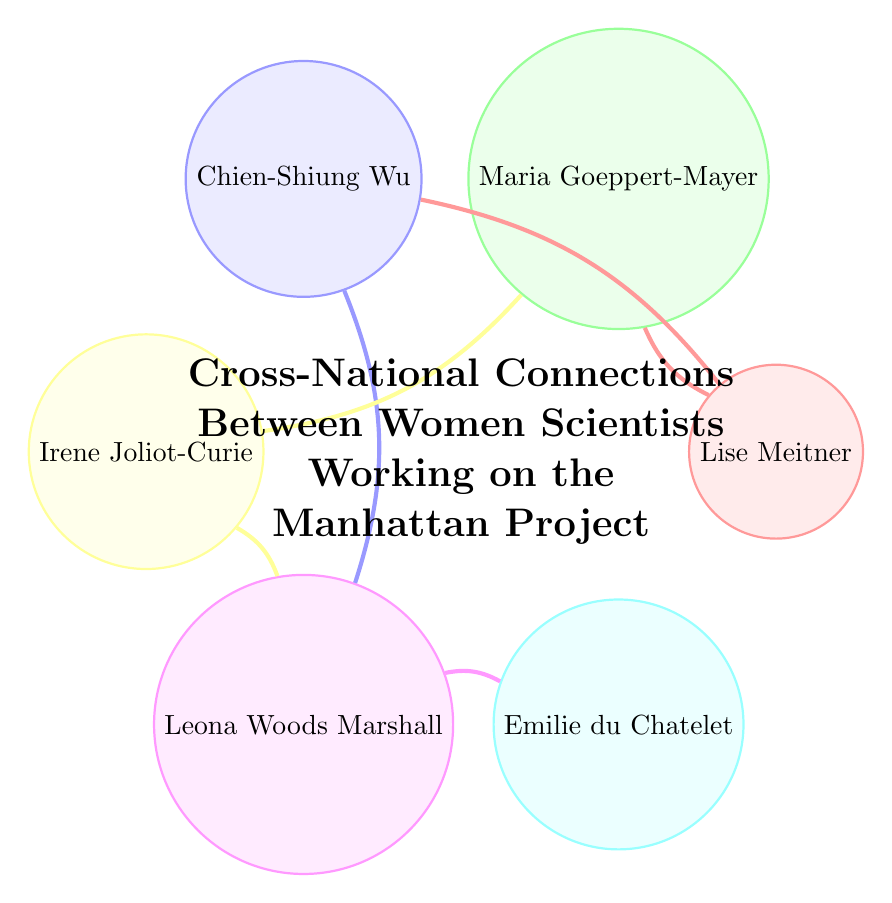How many nodes are in the diagram? The diagram shows six distinct names represented as nodes: Lise Meitner, Maria Goeppert-Mayer, Chien-Shiung Wu, Irene Joliot-Curie, Leona Woods Marshall, and Emilie du Chatelet.
Answer: 6 What is the connection between Lise Meitner and Chien-Shiung Wu? In the diagram, there is a direct link represented between Lise Meitner and Chien-Shiung Wu, indicating they are connected.
Answer: Connected How many total connections (links) are present in the diagram? The diagram displays six connections linking different nodes together, each showing interactions among the women scientists.
Answer: 6 Which node has connections to the most other nodes? Upon examining the diagram, Leona Woods Marshall connects with three nodes: Chien-Shiung Wu, Irene Joliot-Curie, and Emilie du Chatelet.
Answer: Leona Woods Marshall What connections does Irene Joliot-Curie have? Irene Joliot-Curie is connected to two nodes: Maria Goeppert-Mayer and Leona Woods Marshall, indicating her relationships with both.
Answer: Maria Goeppert-Mayer, Leona Woods Marshall Which two nodes are directly connected without another node in between? The direct connection without any intermediary node exists between Lise Meitner and Maria Goeppert-Mayer, which creates a straight link.
Answer: Lise Meitner and Maria Goeppert-Mayer What is the significance of the value "1" in the links? The value "1" denotes that each connection between nodes is a single established link, indicating a straightforward relationship between the two women.
Answer: Single connection How many distinct countries are represented among the nodes in the diagram? To deduce the number of countries, identify the origin of each scientist: Meitner (Austria), Goeppert-Mayer (Germany/USA), Wu (China/USA), Joliot-Curie (France), Woods Marshall (USA), and du Chatelet (France). This analysis reveals three distinct countries represented.
Answer: 3 